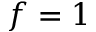<formula> <loc_0><loc_0><loc_500><loc_500>f = 1</formula> 